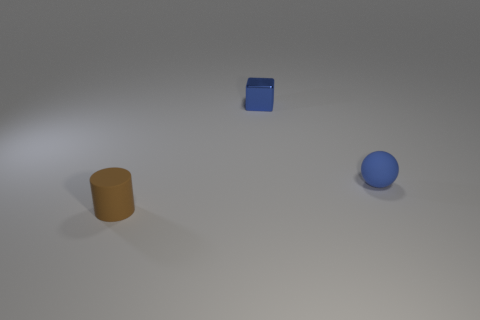Add 2 brown rubber cylinders. How many objects exist? 5 Subtract all spheres. How many objects are left? 2 Subtract all small blue metallic things. Subtract all blue cylinders. How many objects are left? 2 Add 2 tiny blue balls. How many tiny blue balls are left? 3 Add 3 red cylinders. How many red cylinders exist? 3 Subtract 0 purple spheres. How many objects are left? 3 